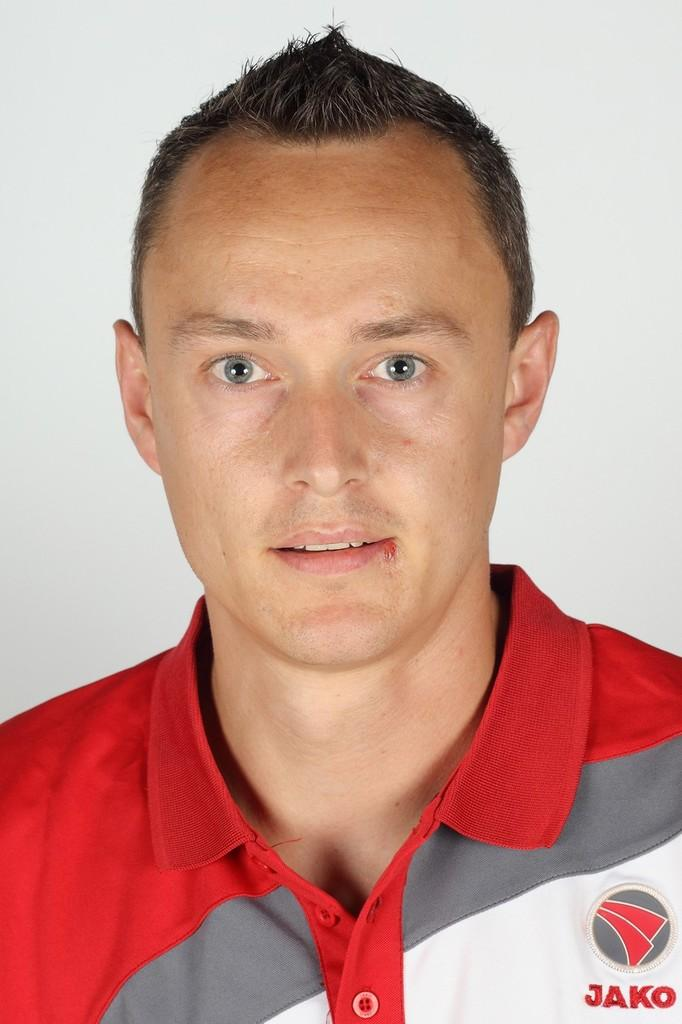<image>
Relay a brief, clear account of the picture shown. The man pictured is wearing a top made by Jako. 